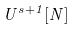Convert formula to latex. <formula><loc_0><loc_0><loc_500><loc_500>U ^ { s + 1 } [ N ]</formula> 